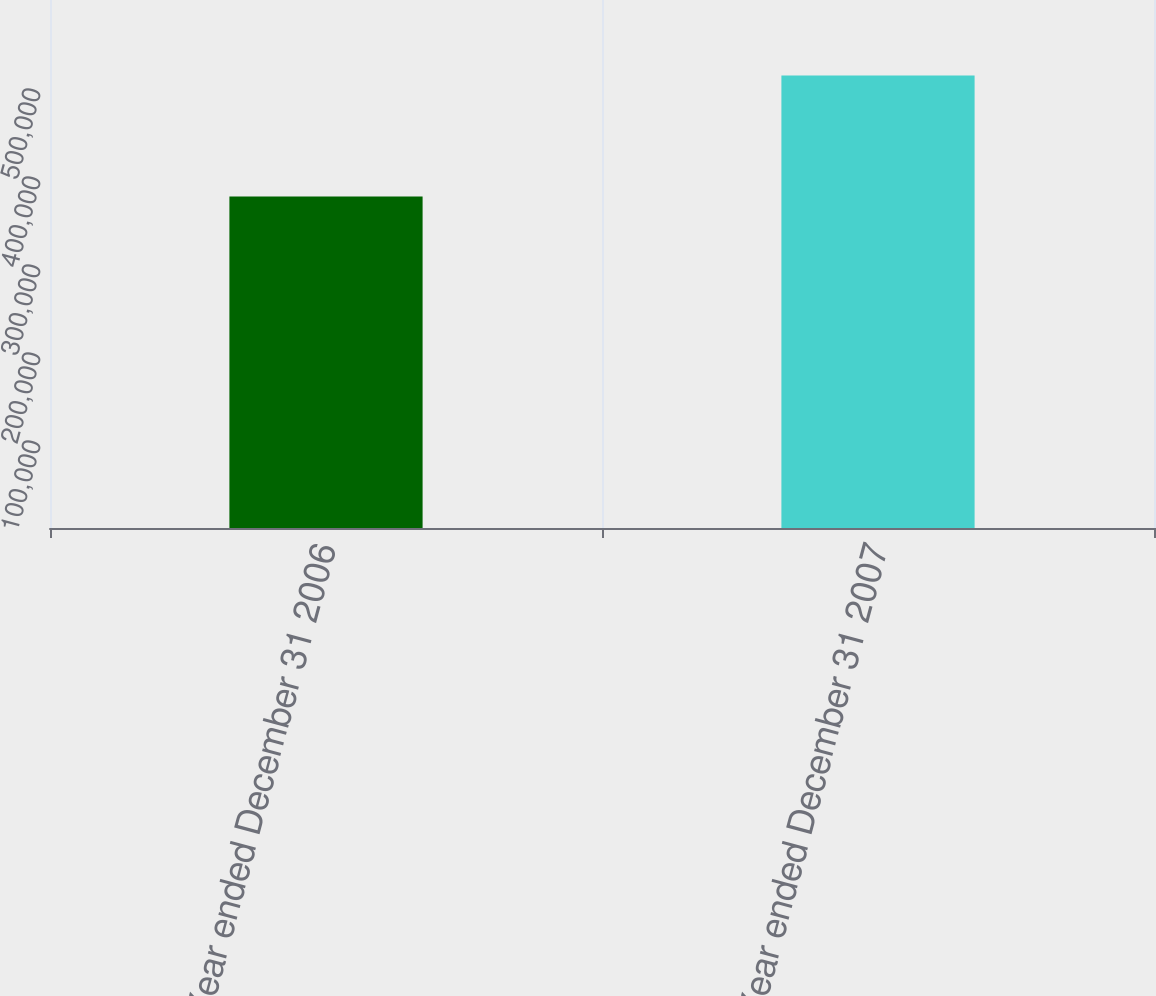Convert chart. <chart><loc_0><loc_0><loc_500><loc_500><bar_chart><fcel>Year ended December 31 2006<fcel>Year ended December 31 2007<nl><fcel>376717<fcel>514198<nl></chart> 